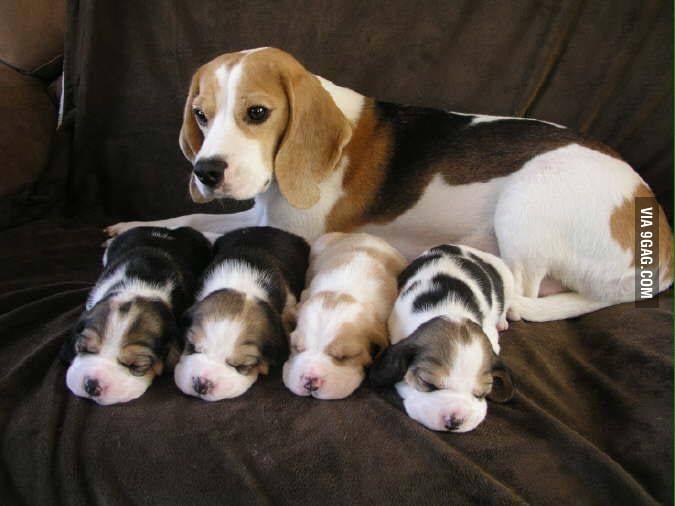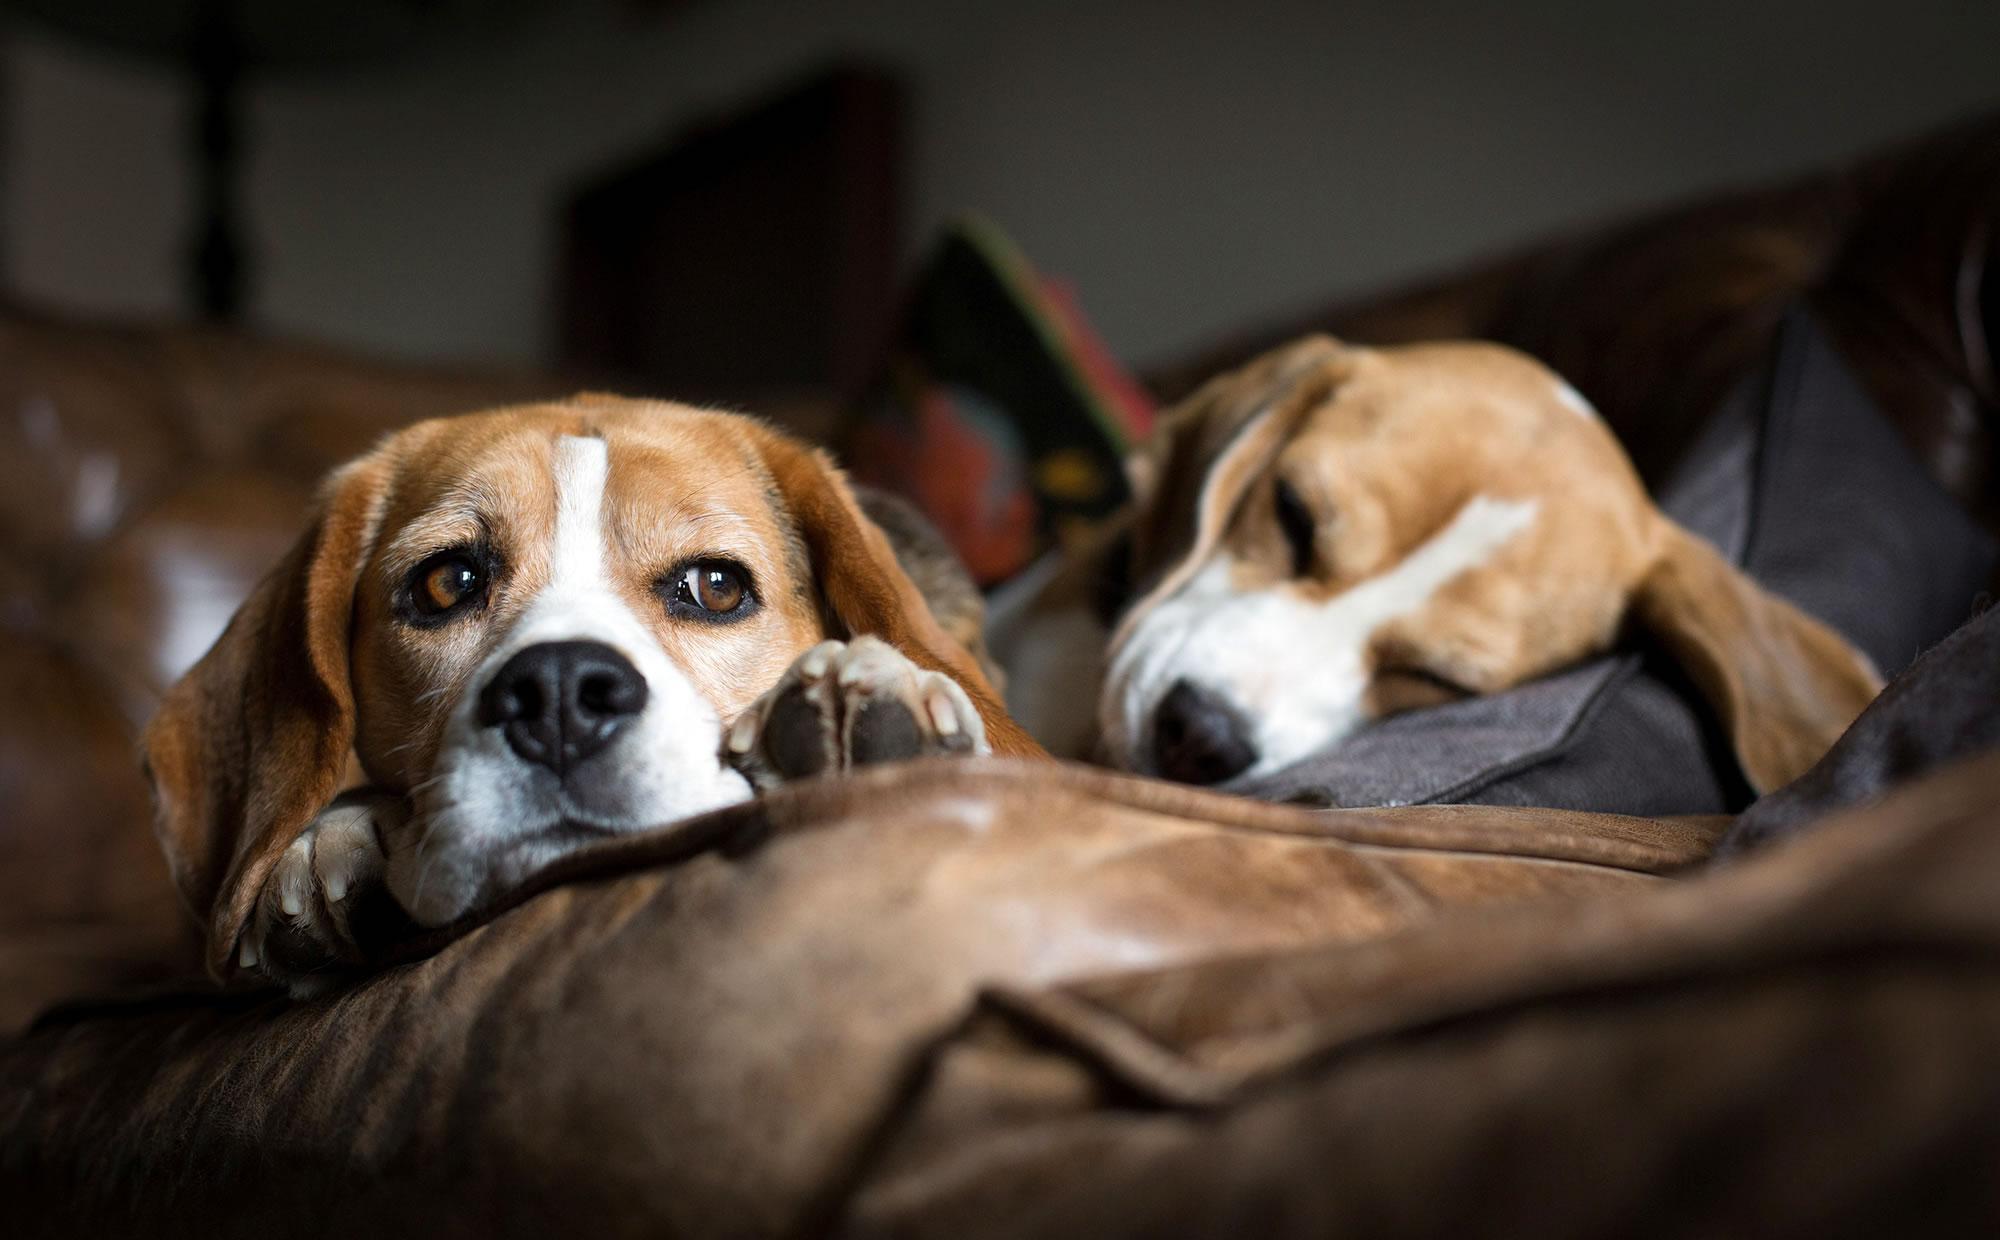The first image is the image on the left, the second image is the image on the right. Assess this claim about the two images: "There are at most two dogs.". Correct or not? Answer yes or no. No. 